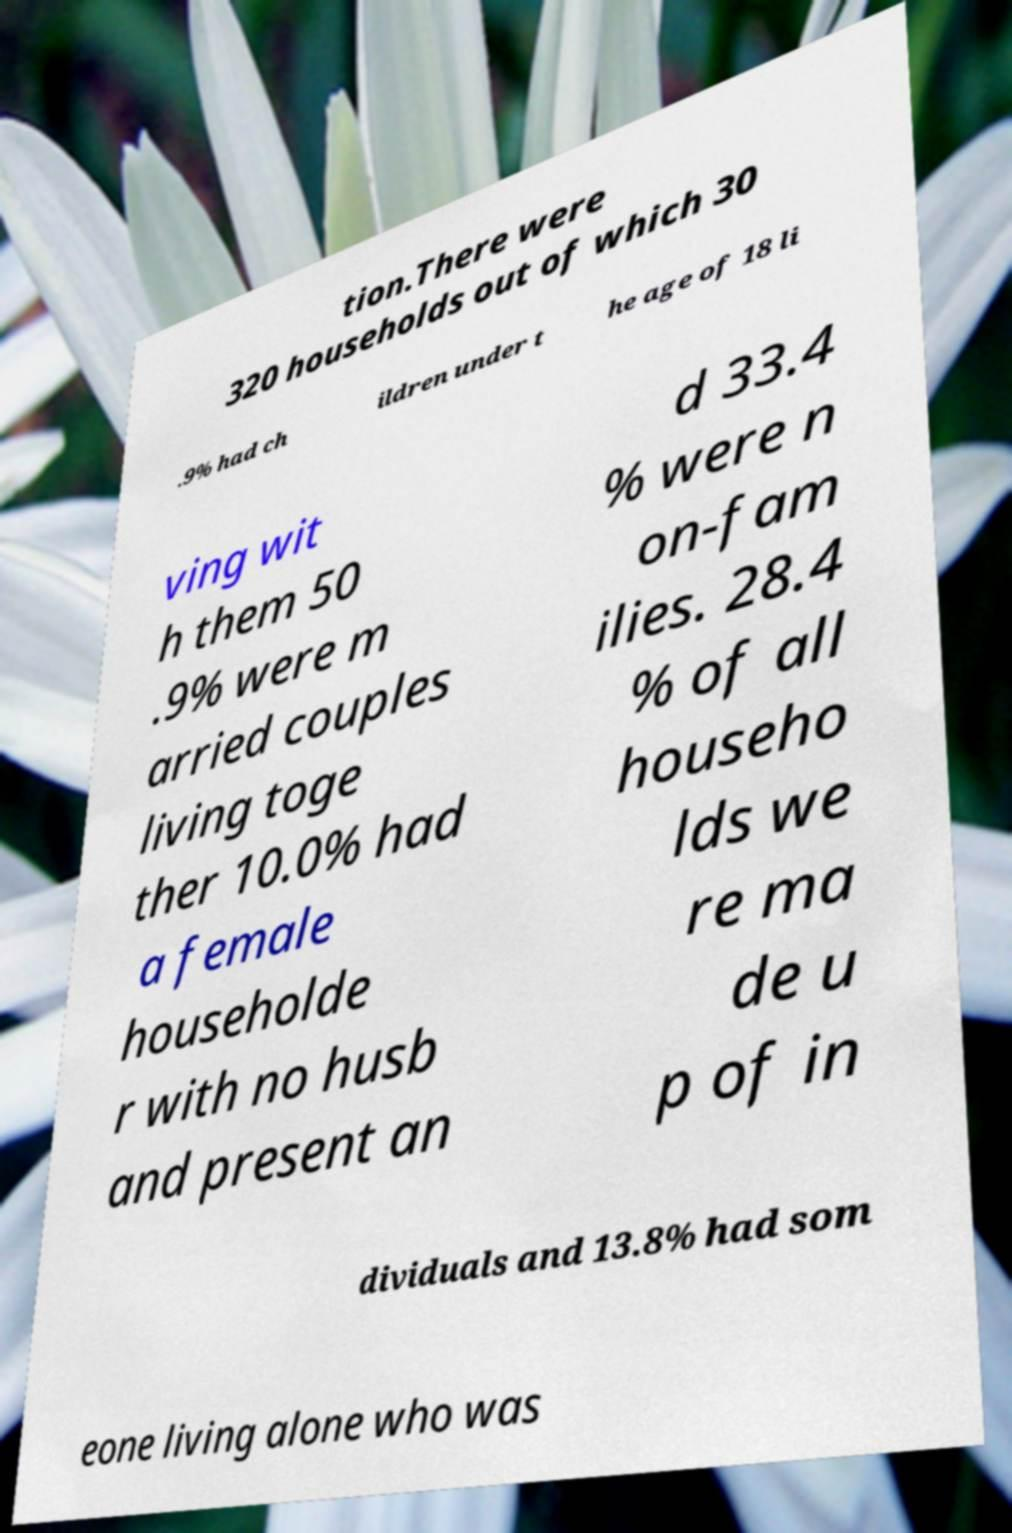What messages or text are displayed in this image? I need them in a readable, typed format. tion.There were 320 households out of which 30 .9% had ch ildren under t he age of 18 li ving wit h them 50 .9% were m arried couples living toge ther 10.0% had a female householde r with no husb and present an d 33.4 % were n on-fam ilies. 28.4 % of all househo lds we re ma de u p of in dividuals and 13.8% had som eone living alone who was 